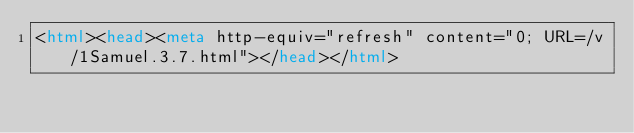<code> <loc_0><loc_0><loc_500><loc_500><_HTML_><html><head><meta http-equiv="refresh" content="0; URL=/v/1Samuel.3.7.html"></head></html></code> 